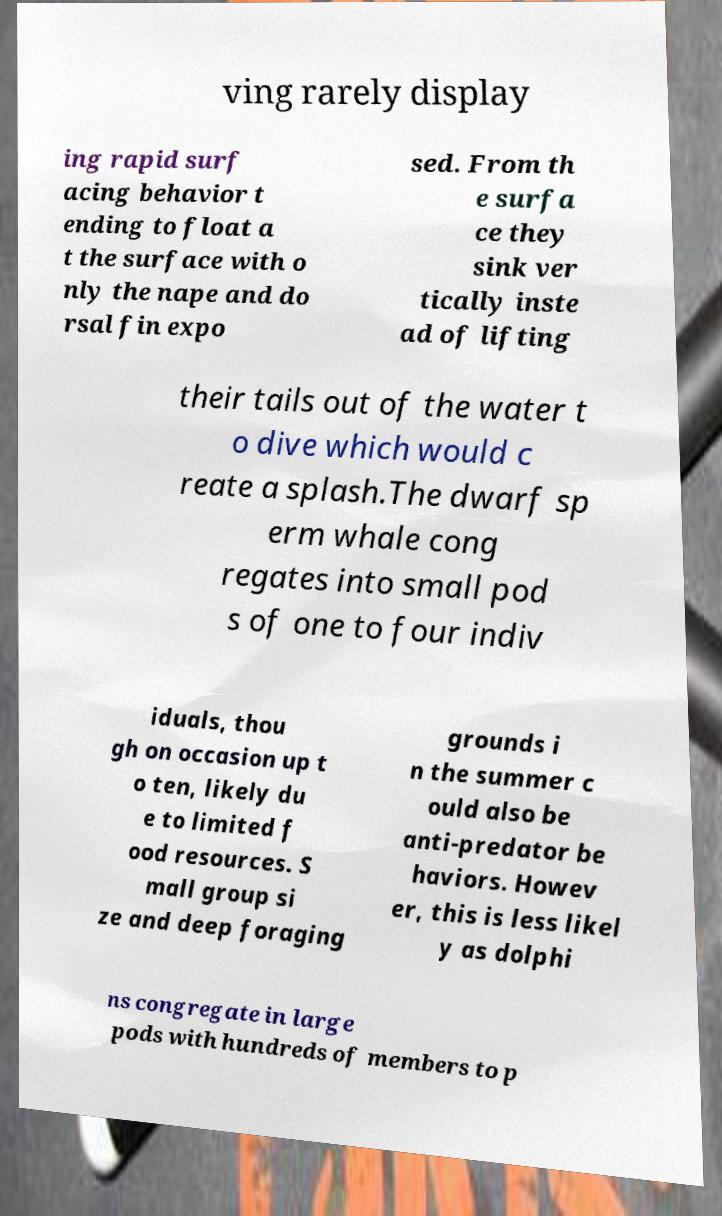Please identify and transcribe the text found in this image. ving rarely display ing rapid surf acing behavior t ending to float a t the surface with o nly the nape and do rsal fin expo sed. From th e surfa ce they sink ver tically inste ad of lifting their tails out of the water t o dive which would c reate a splash.The dwarf sp erm whale cong regates into small pod s of one to four indiv iduals, thou gh on occasion up t o ten, likely du e to limited f ood resources. S mall group si ze and deep foraging grounds i n the summer c ould also be anti-predator be haviors. Howev er, this is less likel y as dolphi ns congregate in large pods with hundreds of members to p 